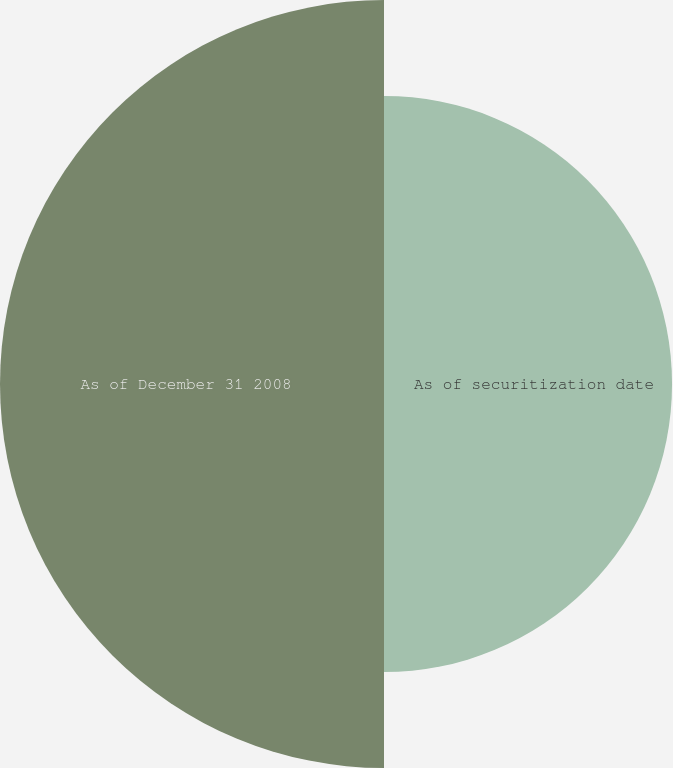<chart> <loc_0><loc_0><loc_500><loc_500><pie_chart><fcel>As of securitization date<fcel>As of December 31 2008<nl><fcel>42.86%<fcel>57.14%<nl></chart> 